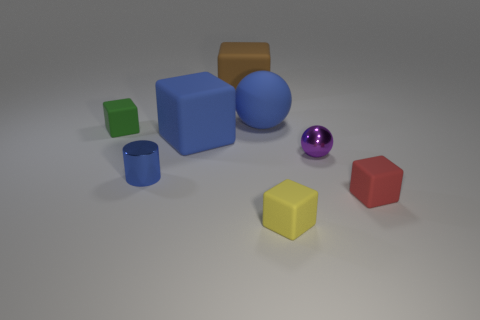Subtract all green blocks. How many blocks are left? 4 Subtract all large blue rubber blocks. How many blocks are left? 4 Subtract all cyan cubes. Subtract all gray balls. How many cubes are left? 5 Add 2 green rubber blocks. How many objects exist? 10 Subtract all cubes. How many objects are left? 3 Subtract 0 yellow cylinders. How many objects are left? 8 Subtract all large brown rubber objects. Subtract all tiny red blocks. How many objects are left? 6 Add 8 shiny balls. How many shiny balls are left? 9 Add 4 big gray objects. How many big gray objects exist? 4 